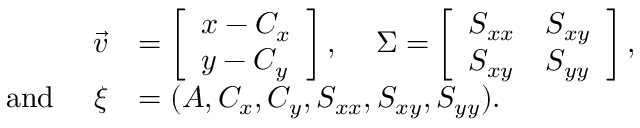<formula> <loc_0><loc_0><loc_500><loc_500>\begin{array} { r l } { \vec { v } } & { = \left [ \begin{array} { l } { x - C _ { x } } \\ { y - C _ { y } } \end{array} \right ] , \Sigma = \left [ \begin{array} { l l } { S _ { x x } } & { S _ { x y } } \\ { S _ { x y } } & { S _ { y y } } \end{array} \right ] , } \\ { a n d \xi } & { = ( A , C _ { x } , C _ { y } , S _ { x x } , S _ { x y } , S _ { y y } ) . } \end{array}</formula> 